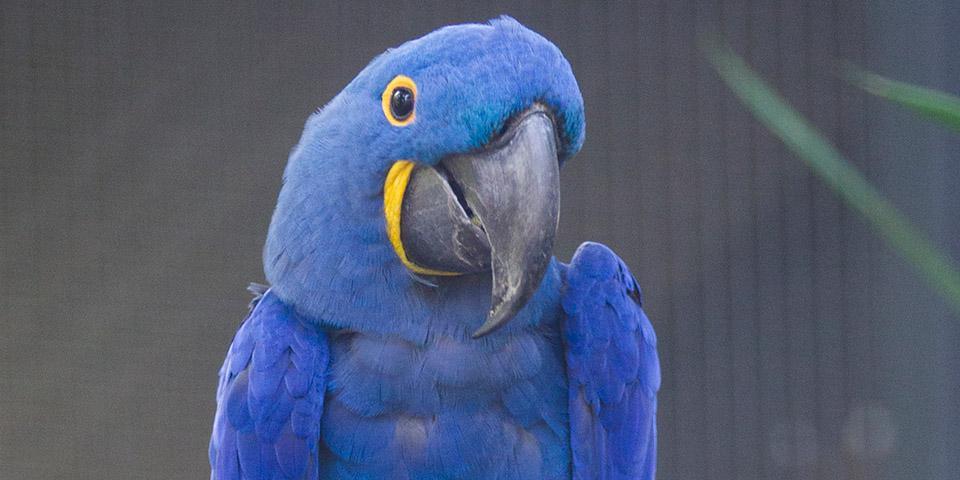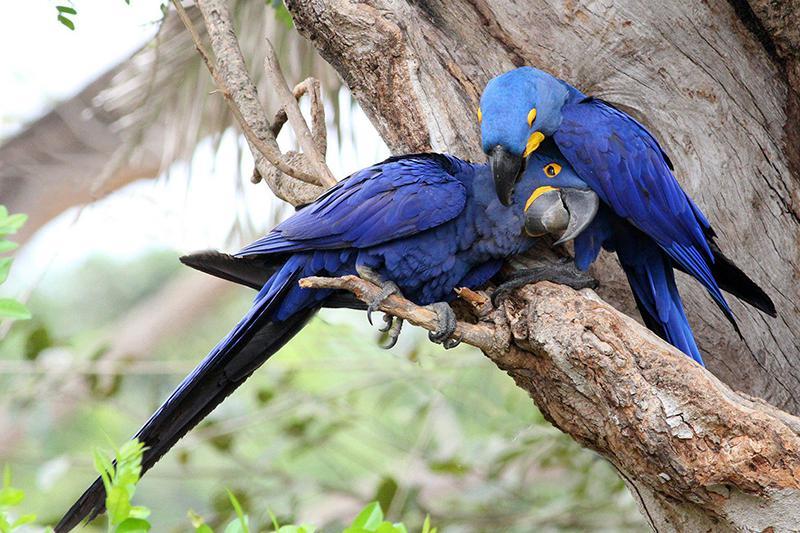The first image is the image on the left, the second image is the image on the right. For the images displayed, is the sentence "One image contains twice as many blue parrots as the other image, and an image shows two birds perched on something made of wood." factually correct? Answer yes or no. Yes. The first image is the image on the left, the second image is the image on the right. Assess this claim about the two images: "There are three blue parrots.". Correct or not? Answer yes or no. Yes. 